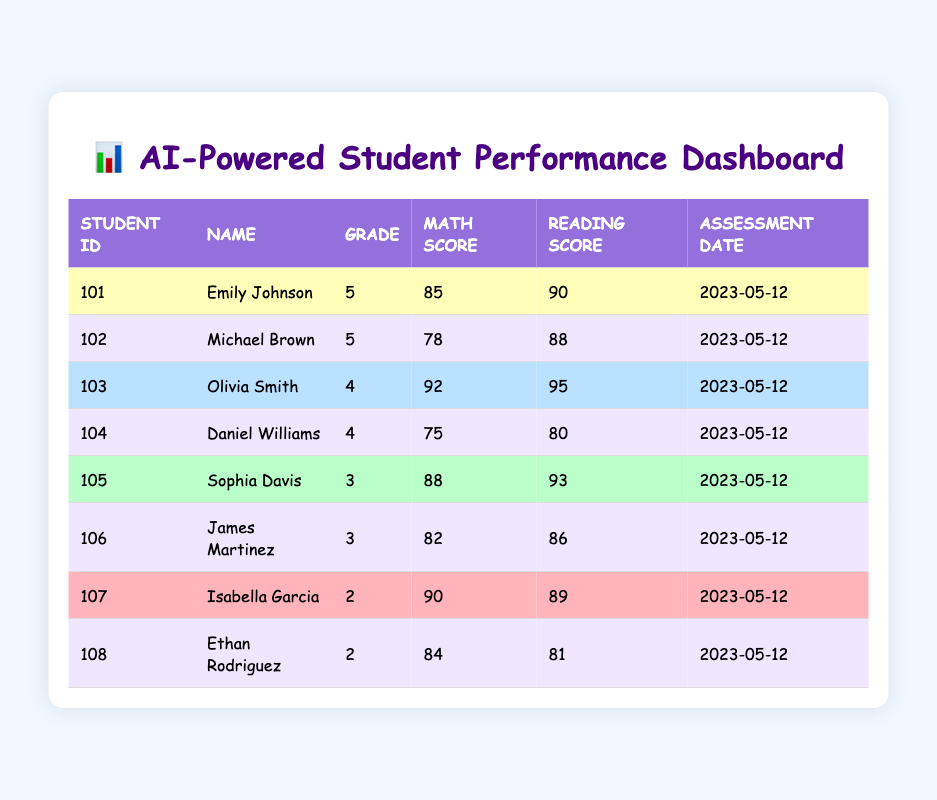What is the highest math score among the students? The scores in the math column are 85, 78, 92, 75, 88, 82, 90, and 84. The highest score is 92, which belongs to Olivia Smith.
Answer: 92 What is the average reading score for grade 3 students? The reading scores for grade 3 students are 93 and 86. To calculate the average, sum these scores: 93 + 86 = 179, and then divide by the number of students (2): 179 / 2 = 89.5.
Answer: 89.5 Did any student achieve a higher reading score than their math score? Comparing math and reading scores, Emily Johnson (85 vs 90), Olivia Smith (92 vs 95), Sophia Davis (88 vs 93), and Isabella Garcia (90 vs 89) all achieved higher reading scores than math scores.
Answer: Yes Who is the student with the lowest math score? The math scores are 85, 78, 92, 75, 88, 82, 90, and 84. The lowest score is 75, which belongs to Daniel Williams.
Answer: Daniel Williams What is the difference between the highest reading score and the lowest reading score? The highest reading score is 95 (Olivia Smith) and the lowest is 80 (Daniel Williams). The difference is calculated as follows: 95 - 80 = 15.
Answer: 15 How many students have a math score above 80? The students with math scores above 80 are Emily Johnson (85), Olivia Smith (92), Sophia Davis (88), James Martinez (82), and Isabella Garcia (90). This totals 5 students.
Answer: 5 Which student scored the highest overall (combined math and reading scores)? The overall scores are calculated as follows: Emily Johnson (175), Michael Brown (166), Olivia Smith (187), Daniel Williams (155), Sophia Davis (181), James Martinez (168), Isabella Garcia (179), and Ethan Rodriguez (165). The highest combined score is 187 for Olivia Smith.
Answer: Olivia Smith What percentage of students scored above 85 in math? The students scoring above 85 in math are Emily Johnson (85), Olivia Smith (92), Sophia Davis (88), James Martinez (82), and Isabella Garcia (90). This gives us 4 out of 8 students, which is (4 / 8) x 100 = 50%.
Answer: 50% 